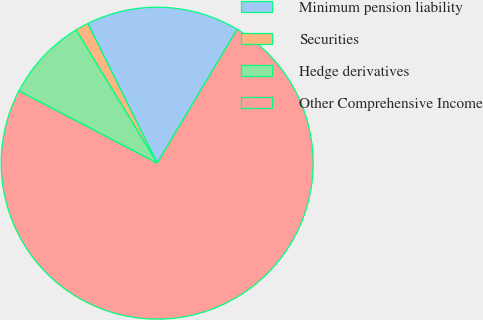Convert chart. <chart><loc_0><loc_0><loc_500><loc_500><pie_chart><fcel>Minimum pension liability<fcel>Securities<fcel>Hedge derivatives<fcel>Other Comprehensive Income<nl><fcel>15.91%<fcel>1.37%<fcel>8.64%<fcel>74.08%<nl></chart> 